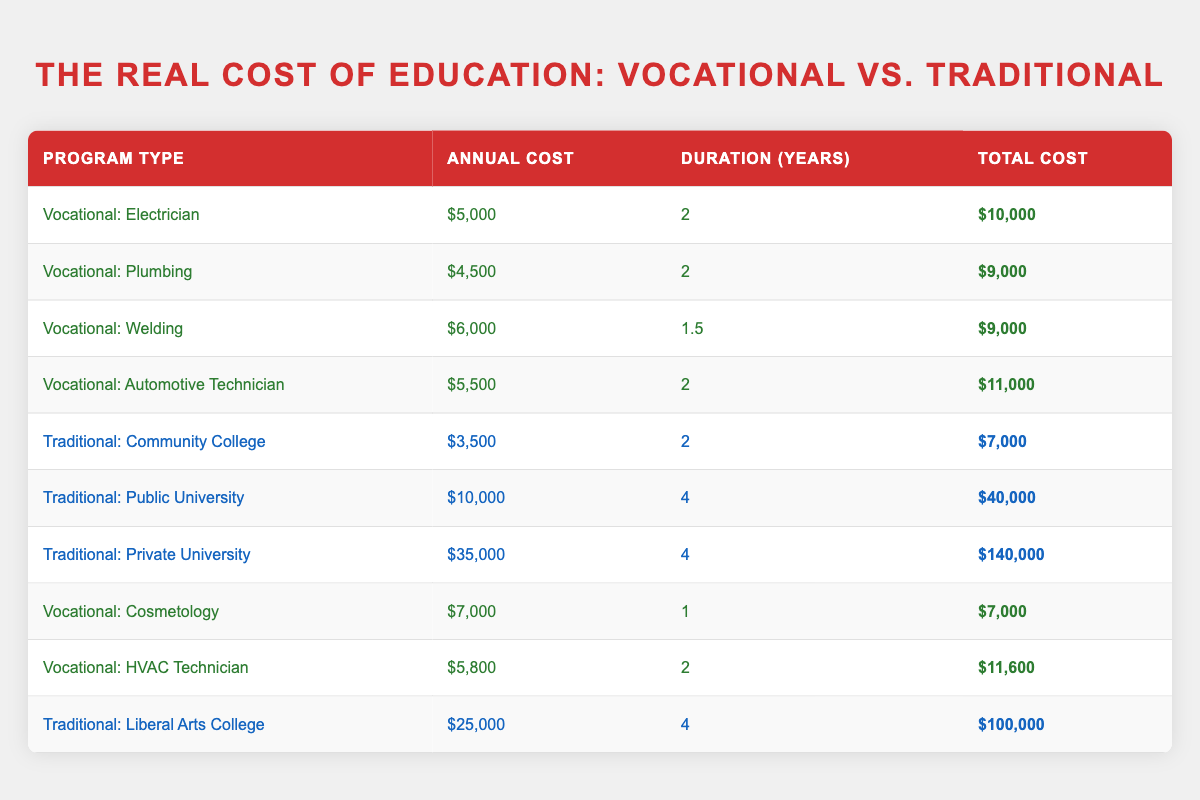What is the total cost of the Vocational: Electrician program? The total cost of the Vocational: Electrician program is explicitly listed in the table as $10,000.
Answer: $10,000 Which traditional college has the highest annual cost? The table shows that the Traditional: Private University has the highest annual cost at $35,000.
Answer: $35,000 What is the average total cost of all vocational programs listed? First, identify the total costs of all vocational programs: $10,000 + $9,000 + $9,000 + $11,000 + $7,000 + $11,600 = $57,600. Then, divide by the number of vocational programs (6): $57,600 / 6 = $9,600.
Answer: $9,600 Is the total cost of the Traditional: Community College higher than that of all vocational programs combined? The total cost of the Traditional: Community College is $7,000. The combined total cost of all vocational programs is $10,000 + $9,000 + $9,000 + $11,000 + $7,000 + $11,600 = $57,600. $7,000 is less than $57,600, making the statement false.
Answer: No What is the difference in total cost between the Traditional: Public University and the Vocational: Automotive Technician? The total cost of the Traditional: Public University is $40,000 while the Vocational: Automotive Technician is $11,000. To find the difference, subtract: $40,000 - $11,000 = $29,000.
Answer: $29,000 Which vocational training program has the shortest duration? The table shows that the Vocational: Cosmetology program has the shortest duration of 1 year.
Answer: 1 year Are all traditional college programs more expensive than vocational training programs? Comparing the costs, the cheapest traditional option (Community College, $7,000) is still slightly more expensive than the vocational options, which range from $4,500 to $35,000. This statement is true because all provided traditional options exceed the costs of vocational programs.
Answer: Yes What is the total cost of all vocational training programs combined? Summing the total costs of the vocational programs: $10,000 + $9,000 + $9,000 + $11,000 + $7,000 + $11,600 = $57,600 gives the total combined cost.
Answer: $57,600 